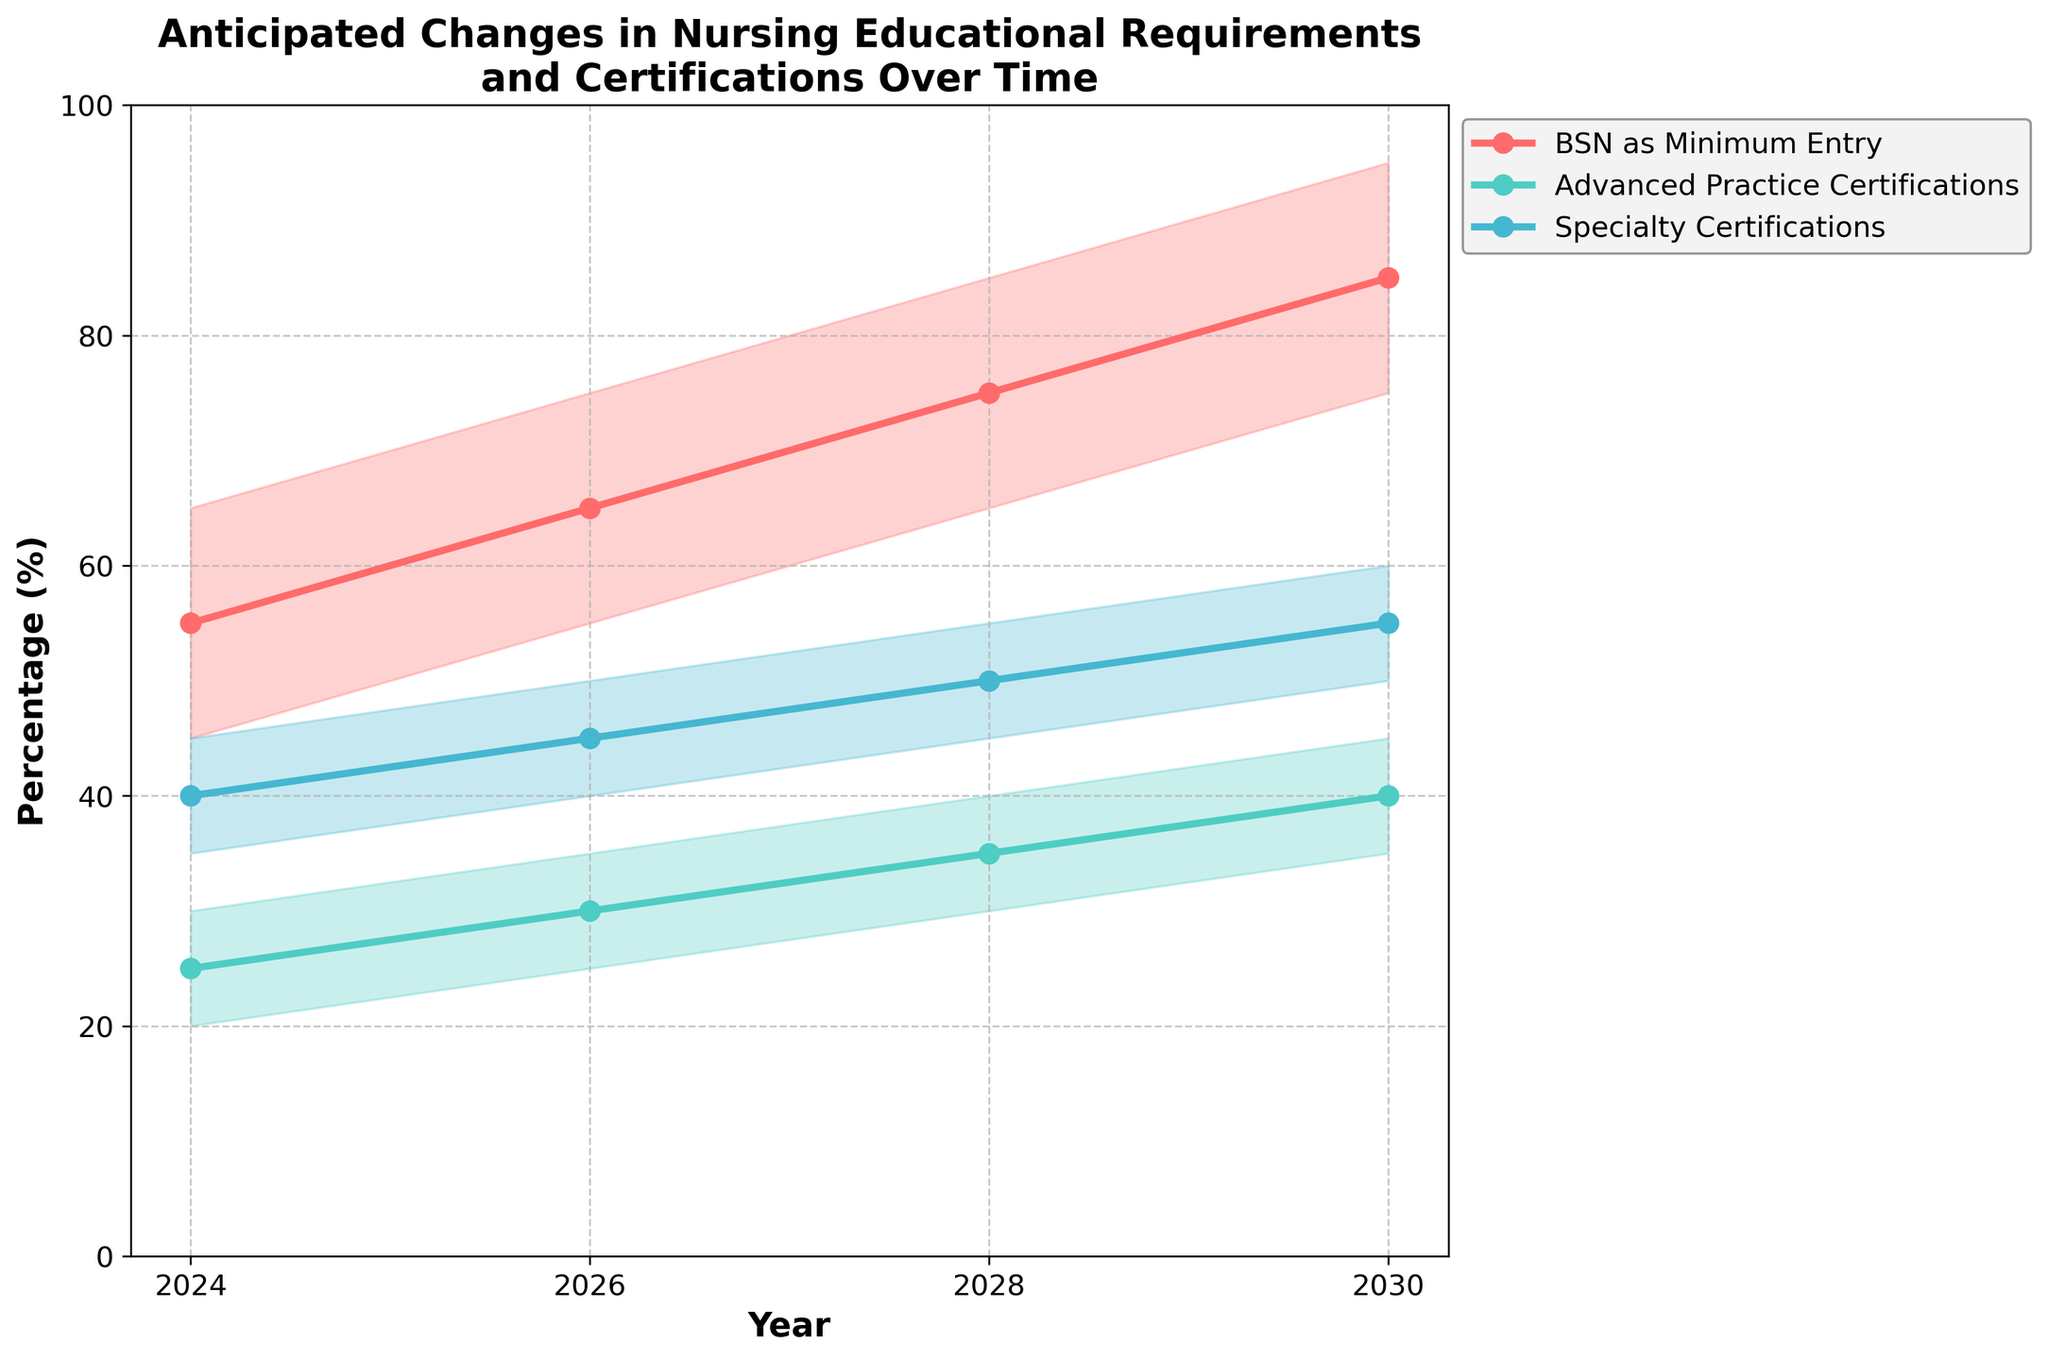What's the title of the figure? The title of the figure is located at the top and describes the main content. It reads "Anticipated Changes in Nursing Educational Requirements and Certifications Over Time".
Answer: Anticipated Changes in Nursing Educational Requirements and Certifications Over Time How do the estimates for "BSN as Minimum Entry" change over time? To answer this, look at the years on the x-axis for the "BSN as Minimum Entry" line and observe the trend of the base estimates. In 2024, it's 55; in 2026, it's 65; in 2028, it's 75; and in 2030, it's 85.
Answer: The base estimates increase over time In what year does the "Specialty Certifications" low estimate reach 50%? Look for the "Specialty Certifications" line and see when the low estimate hits 50 on the y-axis. This happens in 2030.
Answer: 2030 What is the difference between the high and low estimates for "Advanced Practice Certifications" in 2028? To find this, subtract the low estimate from the high estimate for "Advanced Practice Certifications" in 2028. The high estimate is 40 and the low estimate is 30, so 40 - 30 = 10.
Answer: 10 Which requirement has the steepest increase in base estimates between 2024 and 2030? Compare the slope of the lines representing the base estimates of each requirement from 2024 to 2030. "BSN as Minimum Entry" goes from 55 to 85 (a difference of 30), "Advanced Practice Certifications" goes from 25 to 40 (a difference of 15), and "Specialty Certifications" goes from 40 to 55 (a difference of 15). "BSN as Minimum Entry" has the steepest increase.
Answer: BSN as Minimum Entry Which requirement is projected to have the highest base estimate by 2030? Look for the base estimates in the year 2030. "BSN as Minimum Entry" has a base estimate of 85, which is higher than the other requirements' estimates.
Answer: BSN as Minimum Entry How do the high estimates for "Specialty Certifications" change from 2026 to 2030? Observe the high estimates for "Specialty Certifications" between 2026 and 2030. In 2026, it's 50; in 2028, it's 55; and in 2030, it's 60. The estimates increase steadily over these years.
Answer: They increase steadily Are the estimates for "Advanced Practice Certifications" higher or lower than "Specialty Certifications" in 2024? Compare the base estimates for both requirements in 2024. "Advanced Practice Certifications" has a base estimate of 25, while "Specialty Certifications" has a base estimate of 40. Therefore, "Advanced Practice Certifications" are lower.
Answer: Lower What shapes are used to denote the data points along the lines? Look at the markers along each line, which are used to represent data points. Each data point is denoted by a circle.
Answer: Circles 